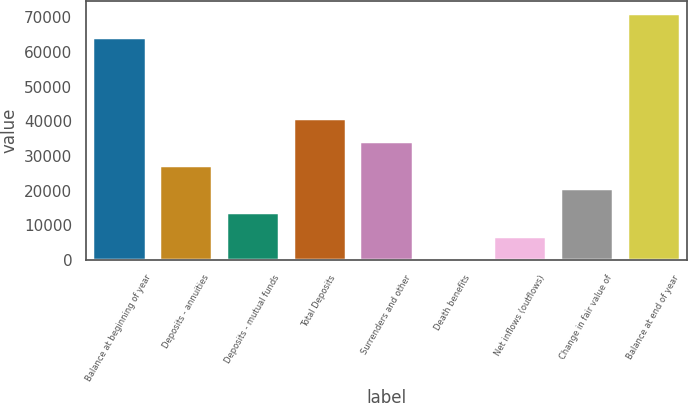Convert chart. <chart><loc_0><loc_0><loc_500><loc_500><bar_chart><fcel>Balance at beginning of year<fcel>Deposits - annuities<fcel>Deposits - mutual funds<fcel>Total Deposits<fcel>Surrenders and other<fcel>Death benefits<fcel>Net inflows (outflows)<fcel>Change in fair value of<fcel>Balance at end of year<nl><fcel>64357<fcel>27400.8<fcel>13831.4<fcel>40970.2<fcel>34185.5<fcel>262<fcel>7046.7<fcel>20616.1<fcel>71141.7<nl></chart> 